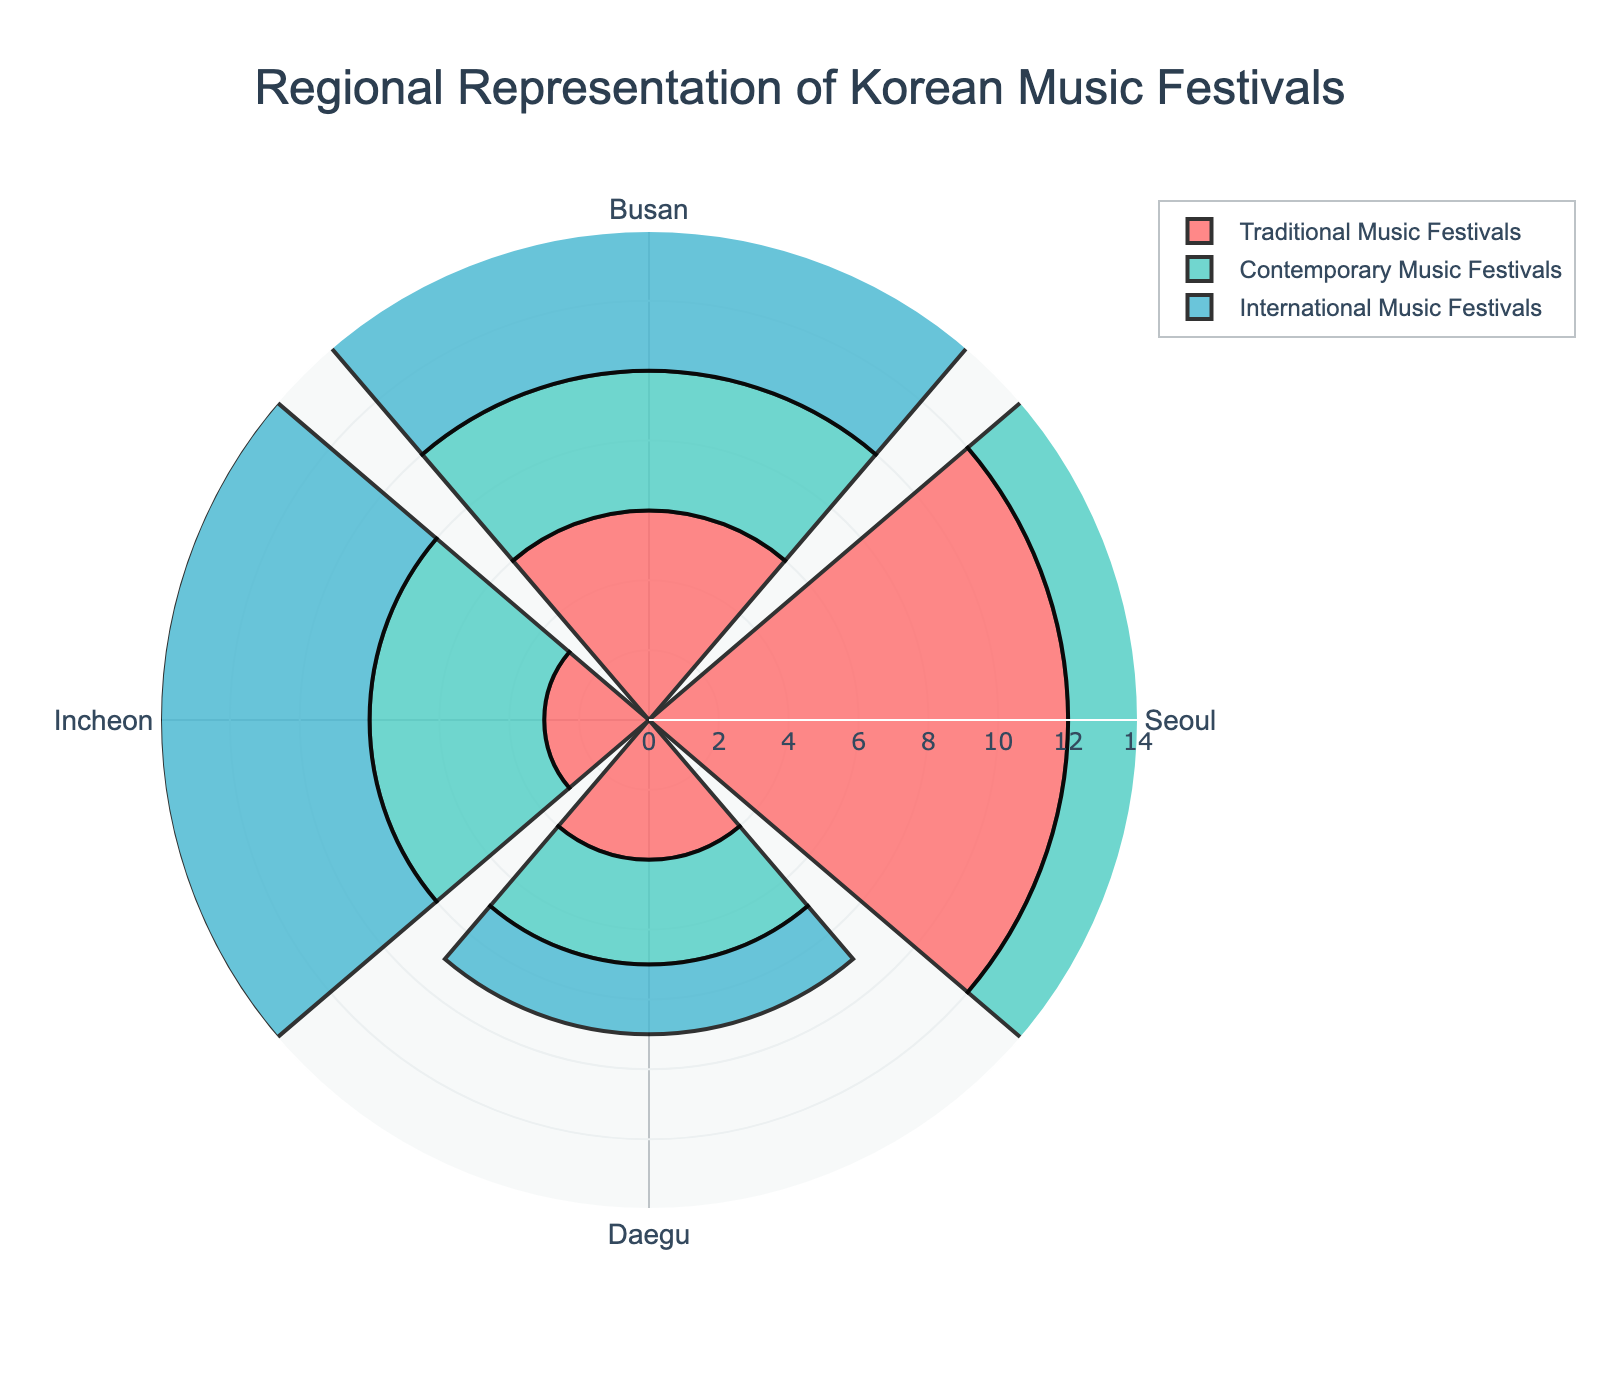What is the title of the rose chart? The title is always prominently displayed at the top of the plot. In this case, it is clearly written in the center.
Answer: Regional Representation of Korean Music Festivals How many regions are represented in the rose chart? There are distinct sections for each region, which are labeled accordingly. Counting the labels will give the answer.
Answer: 4 Which region has the highest number of Traditional Music Festivals? By comparing the length of the bars for Traditional Music Festivals among the regions, the longest bar indicates the highest number.
Answer: Seoul How many Contemporary Music Festivals are held in Incheon? The bar representing Contemporary Music Festivals for Incheon can be observed directly to find the number.
Answer: 5 What is the sum of International Music Festivals in Busan and Seoul? Add the number of International Music Festivals in Busan (7) and Seoul (5): 7 + 5 = 12.
Answer: 12 Which region has the lowest number of International Music Festivals? The shortest bars among the regions for International Music Festivals need to be compared.
Answer: Daegu What is the total number of music festivals in Daegu? Add all types of festivals in Daegu: Traditional (4) + Contemporary (3) + International (2): 4 + 3 + 2 = 9.
Answer: 9 Between Seoul and Busan, which region has more Contemporary Music Festivals? Compare the bars for Contemporary Music Festivals for both regions; the longer bar indicates the higher number.
Answer: Seoul How many more Traditional Music Festivals are there in Seoul compared to Incheon? Subtract the number of Traditional Music Festivals in Incheon (3) from those in Seoul (12): 12 - 3 = 9.
Answer: 9 What is the average number of Contemporary Music Festivals across all regions? Sum the number of Contemporary Music Festivals (8 + 4 + 5 + 3 = 20) and then divide by the number of regions (4): 20 / 4 = 5.
Answer: 5 